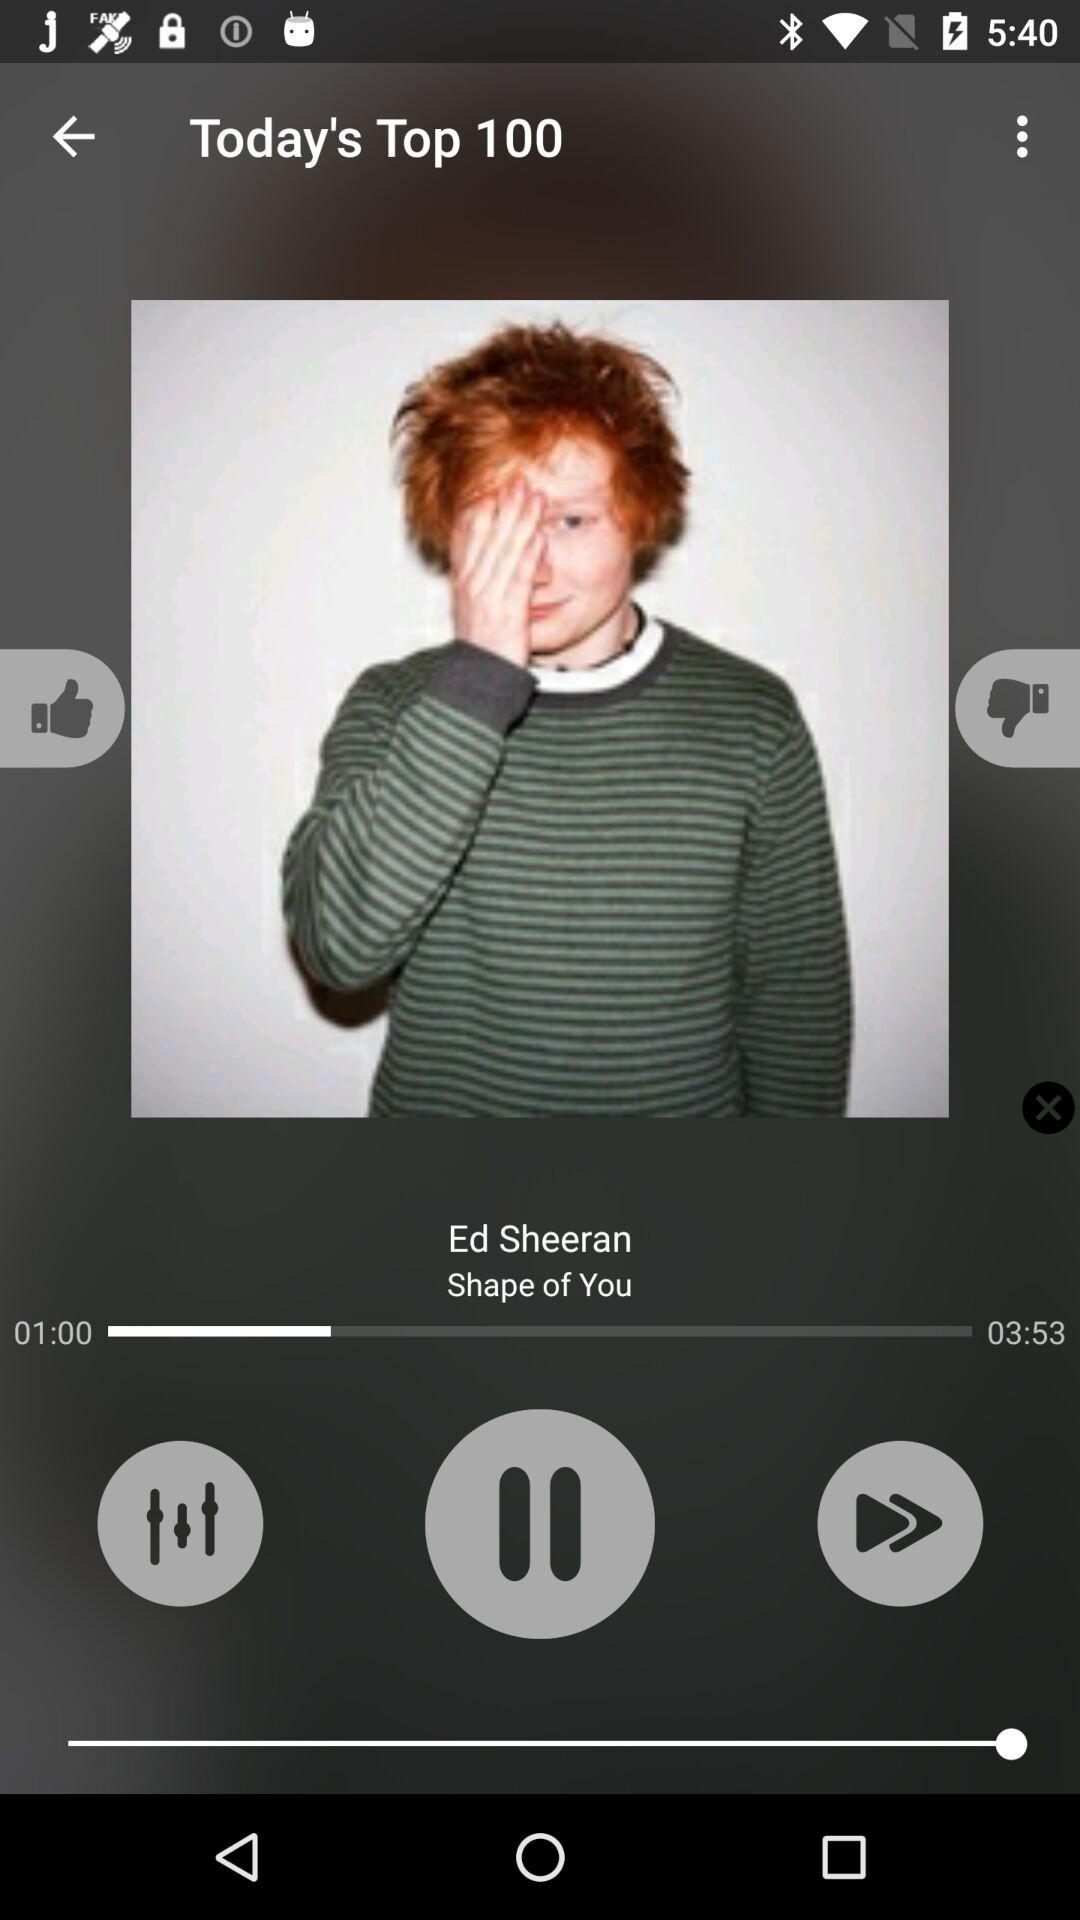What is the name of the singer? The name of the singer is Ed Sheeran. 